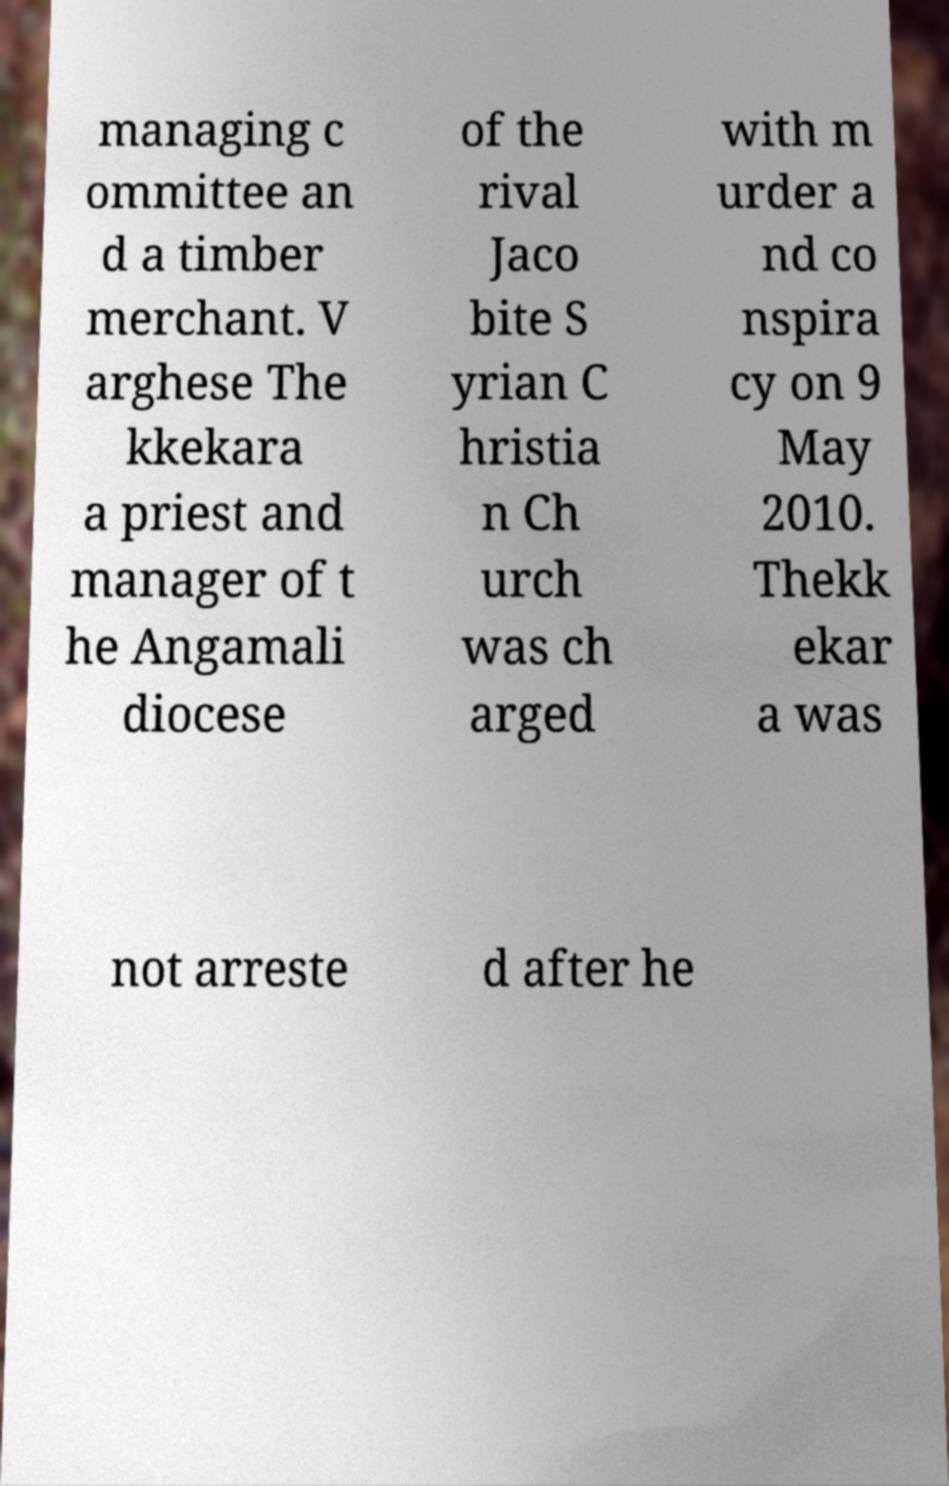Could you assist in decoding the text presented in this image and type it out clearly? managing c ommittee an d a timber merchant. V arghese The kkekara a priest and manager of t he Angamali diocese of the rival Jaco bite S yrian C hristia n Ch urch was ch arged with m urder a nd co nspira cy on 9 May 2010. Thekk ekar a was not arreste d after he 